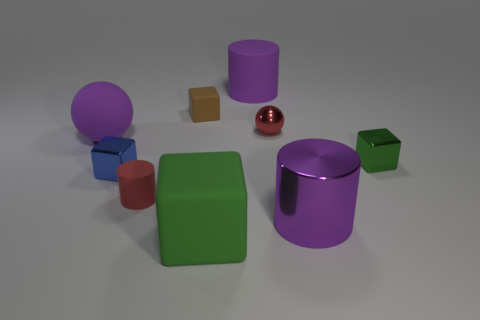What is the material of the large object that is the same shape as the small brown thing? The large object with the same shape as the small brown box appears to be made of a digital matte surface often used in 3D modeling. Its realism and texture suggest it's meant to represent a material that's similar to plastic. 